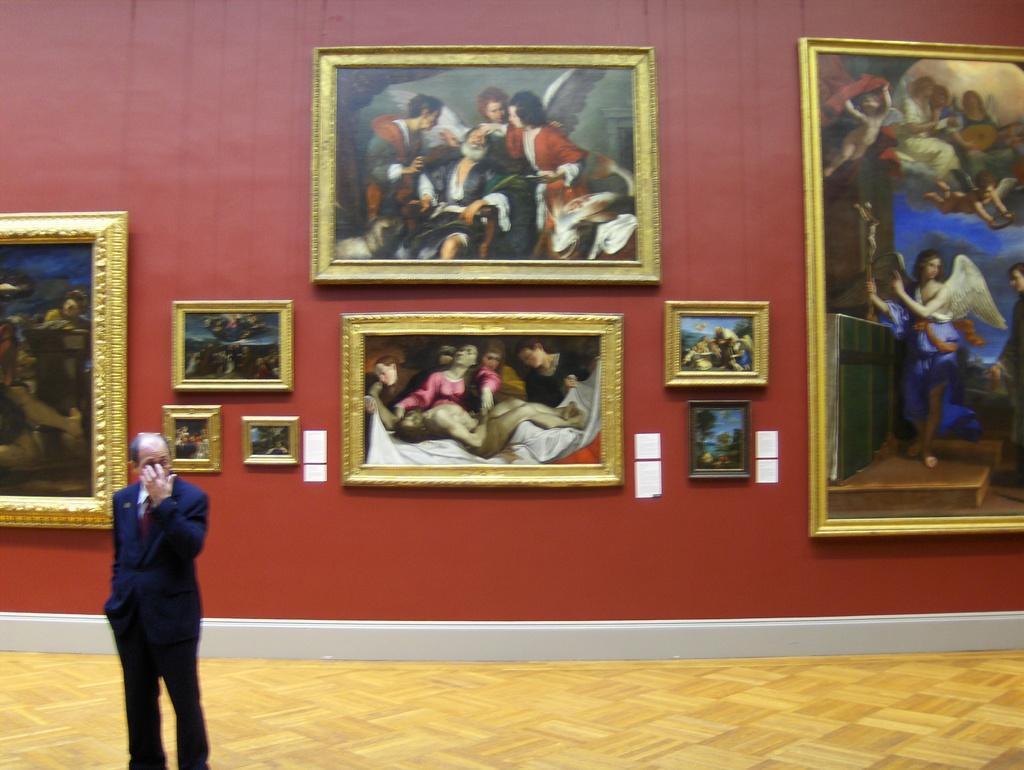Can you describe this image briefly? In this image there is a man who is standing on the floor by keeping his hand on his face. Behind him there is a wall on which there are frames. In the frames we can see there are so many arts. 